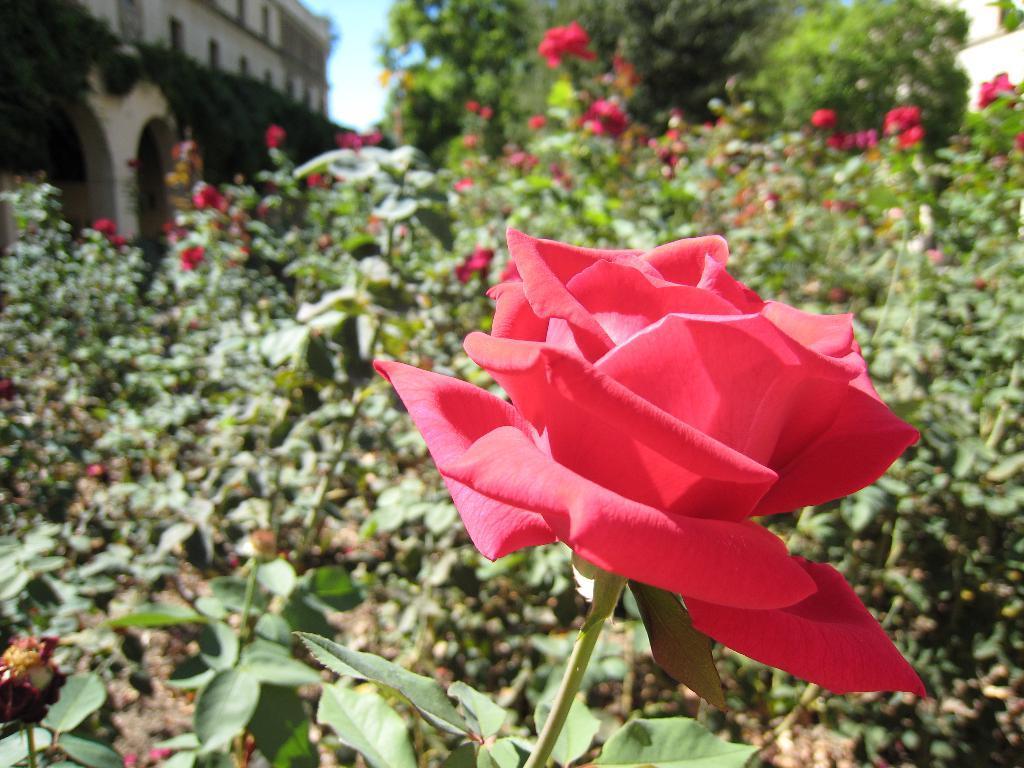Can you describe this image briefly? In this picture we can see rose flowers, plants, trees, building and in the background we can see the sky. 